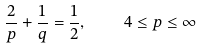<formula> <loc_0><loc_0><loc_500><loc_500>\frac { 2 } p + \frac { 1 } q = \frac { 1 } { 2 } , \quad 4 \leq p \leq \infty</formula> 